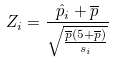Convert formula to latex. <formula><loc_0><loc_0><loc_500><loc_500>Z _ { i } = \frac { \hat { p } _ { i } + \overline { p } } { \sqrt { \frac { \overline { p } ( 5 + \overline { p } ) } { s _ { i } } } }</formula> 